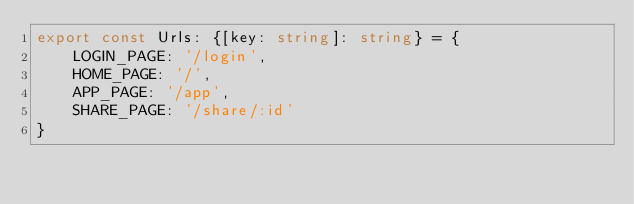Convert code to text. <code><loc_0><loc_0><loc_500><loc_500><_TypeScript_>export const Urls: {[key: string]: string} = {
    LOGIN_PAGE: '/login',
    HOME_PAGE: '/',
    APP_PAGE: '/app',
    SHARE_PAGE: '/share/:id'
}</code> 